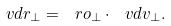Convert formula to latex. <formula><loc_0><loc_0><loc_500><loc_500>\ v d r _ { \perp } = \ r o _ { \perp } \cdot \ v d v _ { \perp } .</formula> 